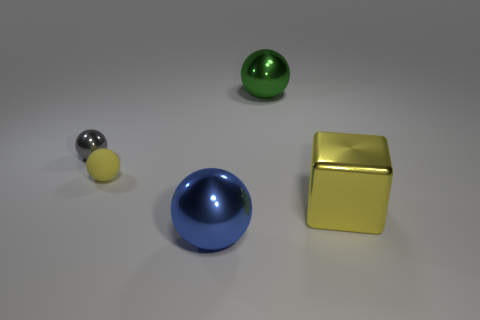There is a object that is in front of the yellow block; is its shape the same as the small thing left of the tiny matte sphere? yes 